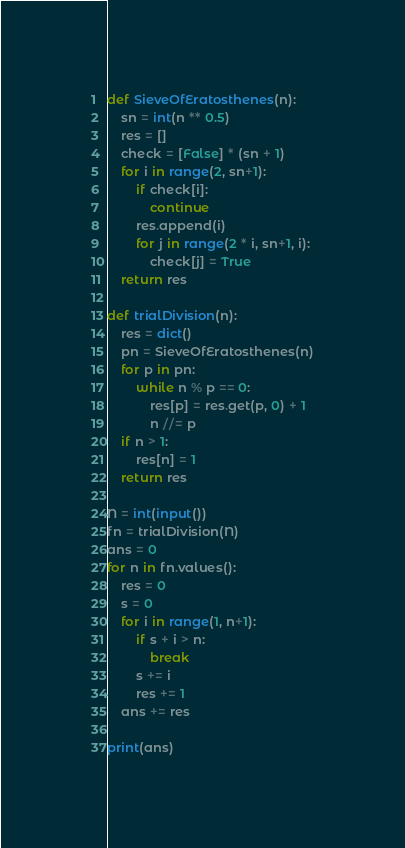Convert code to text. <code><loc_0><loc_0><loc_500><loc_500><_Python_>def SieveOfEratosthenes(n):
    sn = int(n ** 0.5)
    res = []
    check = [False] * (sn + 1)
    for i in range(2, sn+1):
        if check[i]:
            continue
        res.append(i)
        for j in range(2 * i, sn+1, i):
            check[j] = True
    return res

def trialDivision(n):
    res = dict()
    pn = SieveOfEratosthenes(n)
    for p in pn:
        while n % p == 0:
            res[p] = res.get(p, 0) + 1
            n //= p
    if n > 1:
        res[n] = 1
    return res

N = int(input())
fn = trialDivision(N)
ans = 0
for n in fn.values():
    res = 0
    s = 0
    for i in range(1, n+1):
        if s + i > n:
            break
        s += i
        res += 1
    ans += res

print(ans)

</code> 